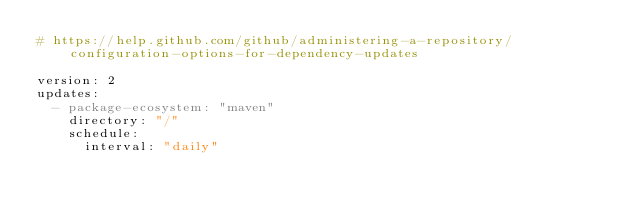Convert code to text. <code><loc_0><loc_0><loc_500><loc_500><_YAML_># https://help.github.com/github/administering-a-repository/configuration-options-for-dependency-updates

version: 2
updates:
  - package-ecosystem: "maven"
    directory: "/"
    schedule:
      interval: "daily"
</code> 